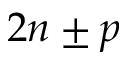Convert formula to latex. <formula><loc_0><loc_0><loc_500><loc_500>2 n \pm p</formula> 